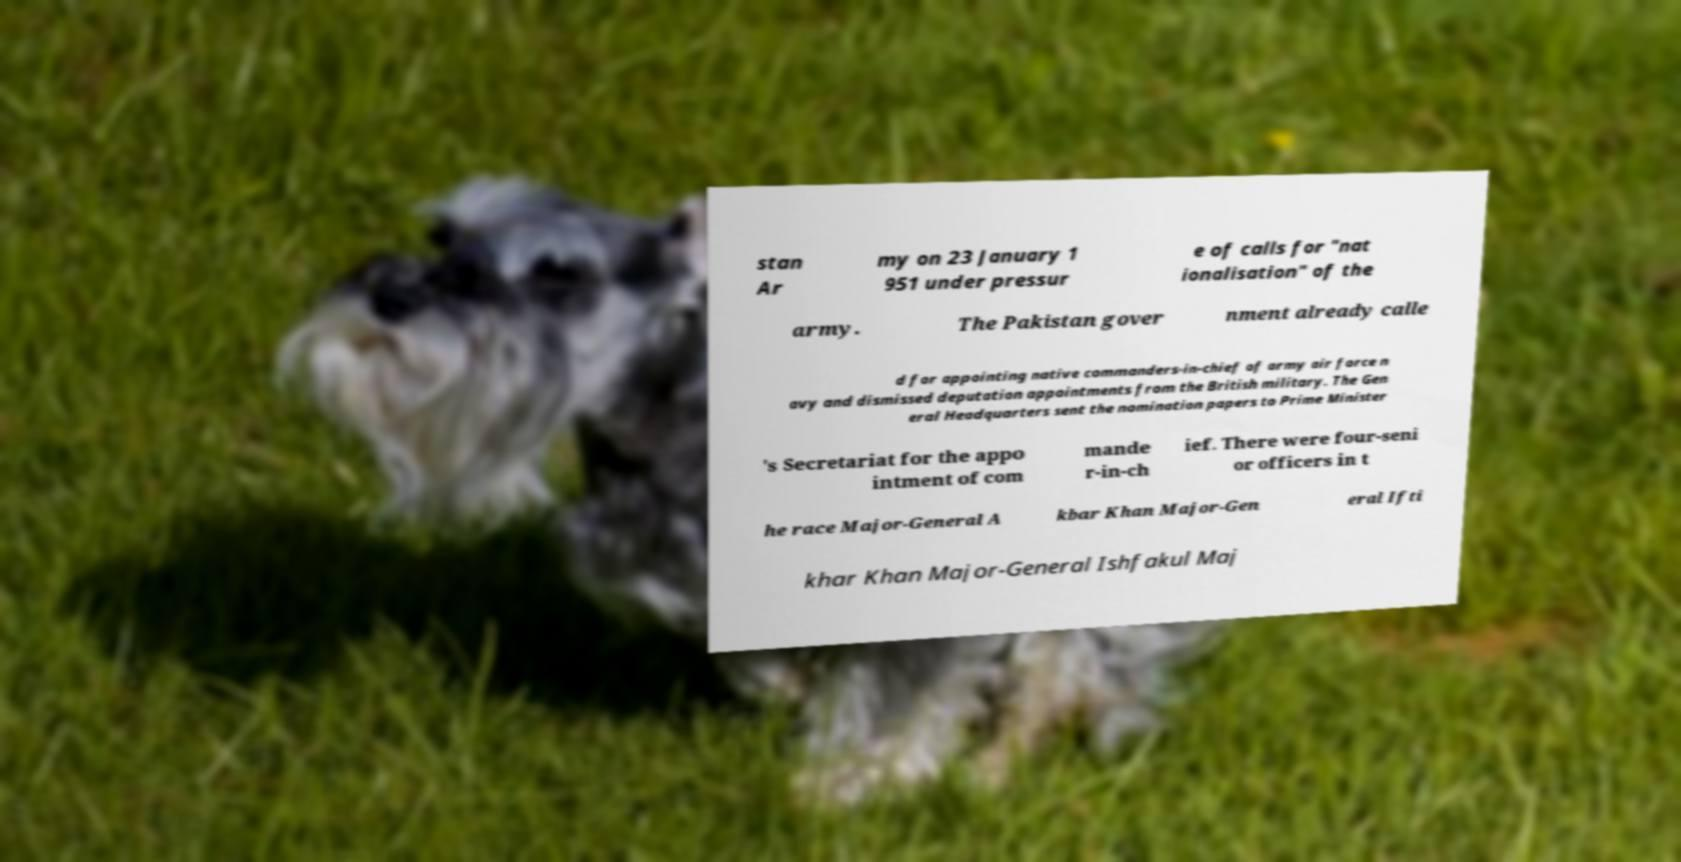Can you accurately transcribe the text from the provided image for me? stan Ar my on 23 January 1 951 under pressur e of calls for "nat ionalisation" of the army. The Pakistan gover nment already calle d for appointing native commanders-in-chief of army air force n avy and dismissed deputation appointments from the British military. The Gen eral Headquarters sent the nomination papers to Prime Minister 's Secretariat for the appo intment of com mande r-in-ch ief. There were four-seni or officers in t he race Major-General A kbar Khan Major-Gen eral Ifti khar Khan Major-General Ishfakul Maj 